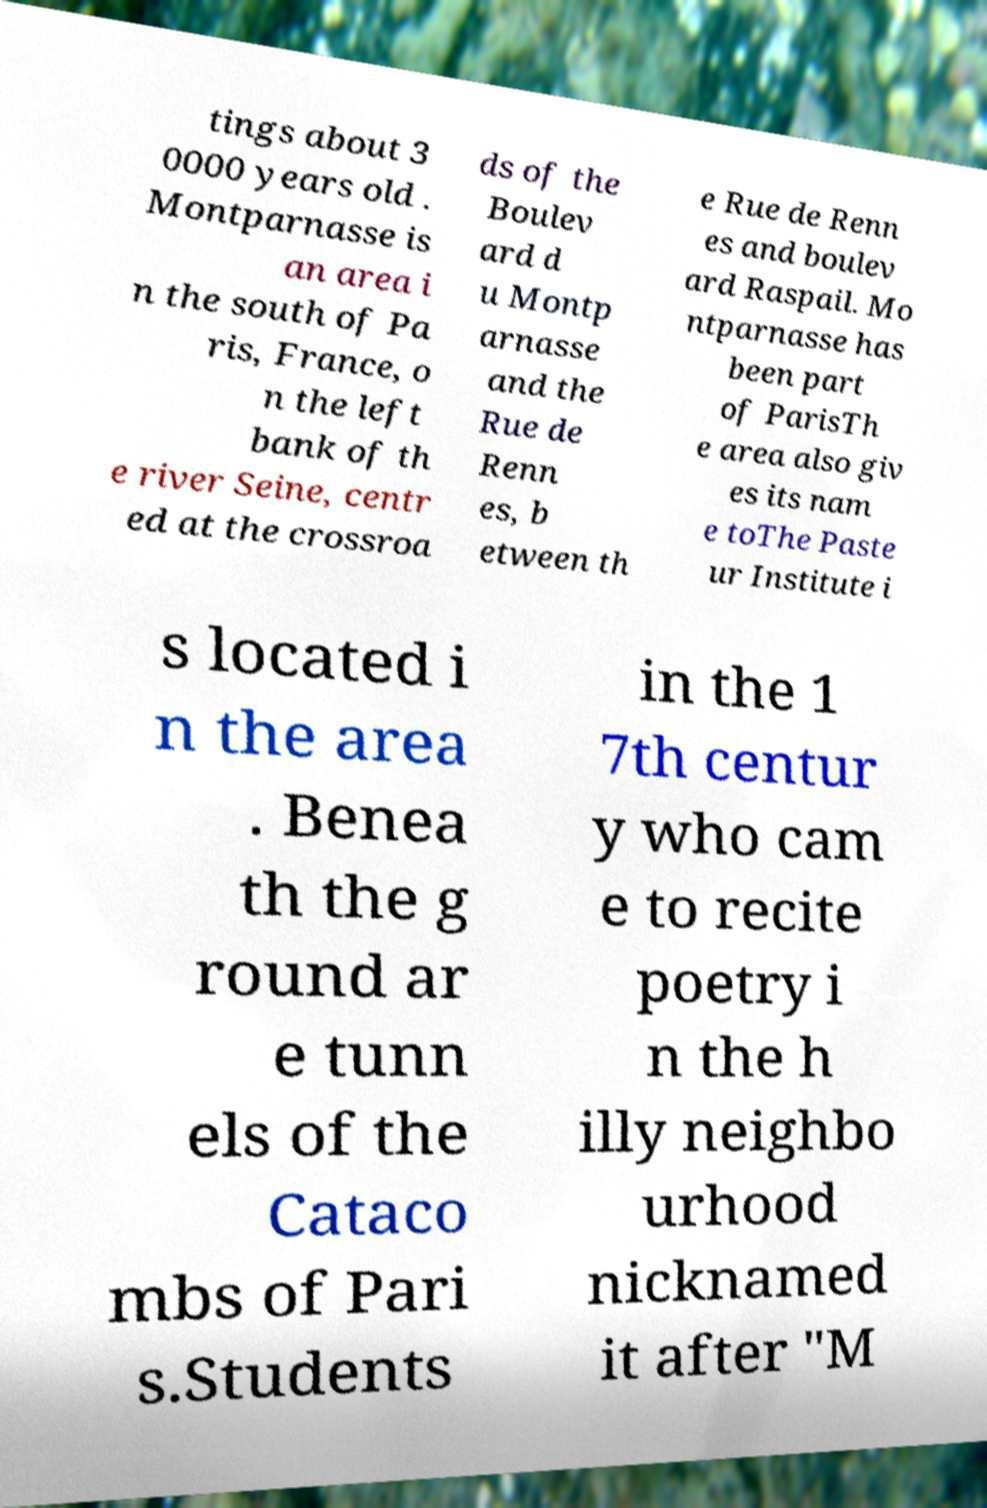I need the written content from this picture converted into text. Can you do that? tings about 3 0000 years old . Montparnasse is an area i n the south of Pa ris, France, o n the left bank of th e river Seine, centr ed at the crossroa ds of the Boulev ard d u Montp arnasse and the Rue de Renn es, b etween th e Rue de Renn es and boulev ard Raspail. Mo ntparnasse has been part of ParisTh e area also giv es its nam e toThe Paste ur Institute i s located i n the area . Benea th the g round ar e tunn els of the Cataco mbs of Pari s.Students in the 1 7th centur y who cam e to recite poetry i n the h illy neighbo urhood nicknamed it after "M 